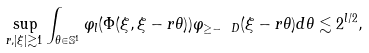Convert formula to latex. <formula><loc_0><loc_0><loc_500><loc_500>\sup _ { r , | \xi | \gtrsim 1 } \int _ { \theta \in \mathbb { S } ^ { 1 } } \varphi _ { l } ( \Phi ( \xi , \xi - r \theta ) ) \varphi _ { \geq - \ D } ( \xi - r \theta ) d \theta \lesssim 2 ^ { l / 2 } ,</formula> 